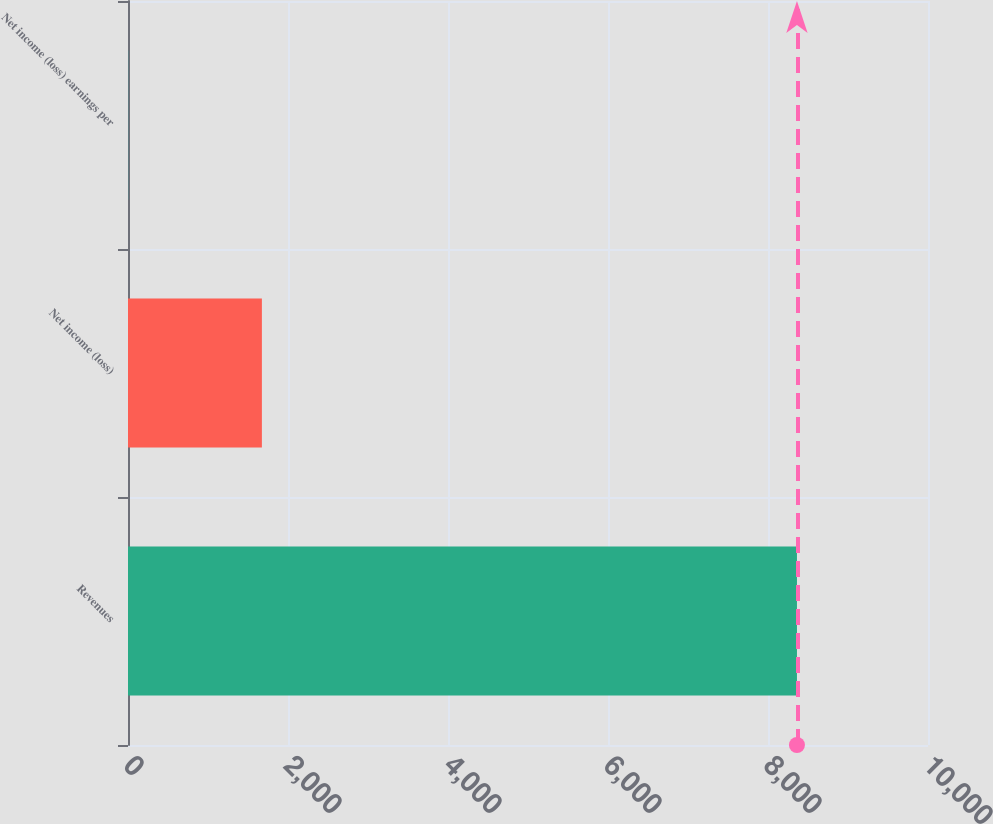<chart> <loc_0><loc_0><loc_500><loc_500><bar_chart><fcel>Revenues<fcel>Net income (loss)<fcel>Net income (loss) earnings per<nl><fcel>8362<fcel>1673.63<fcel>1.53<nl></chart> 